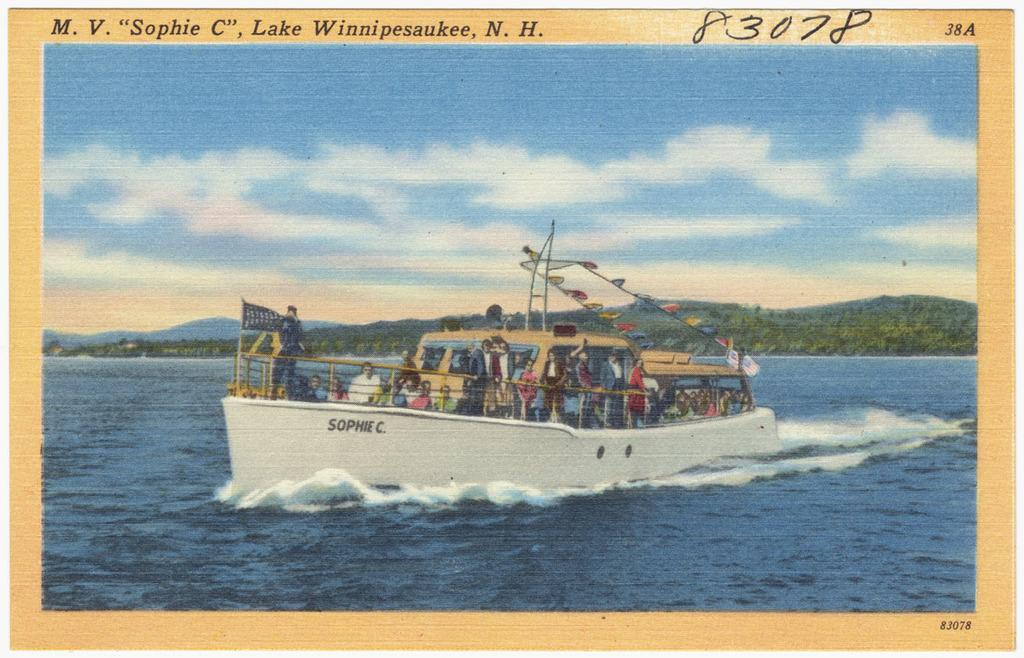<image>
Render a clear and concise summary of the photo. A postcard from Lake Winnipesauke, in New Hampshire. 